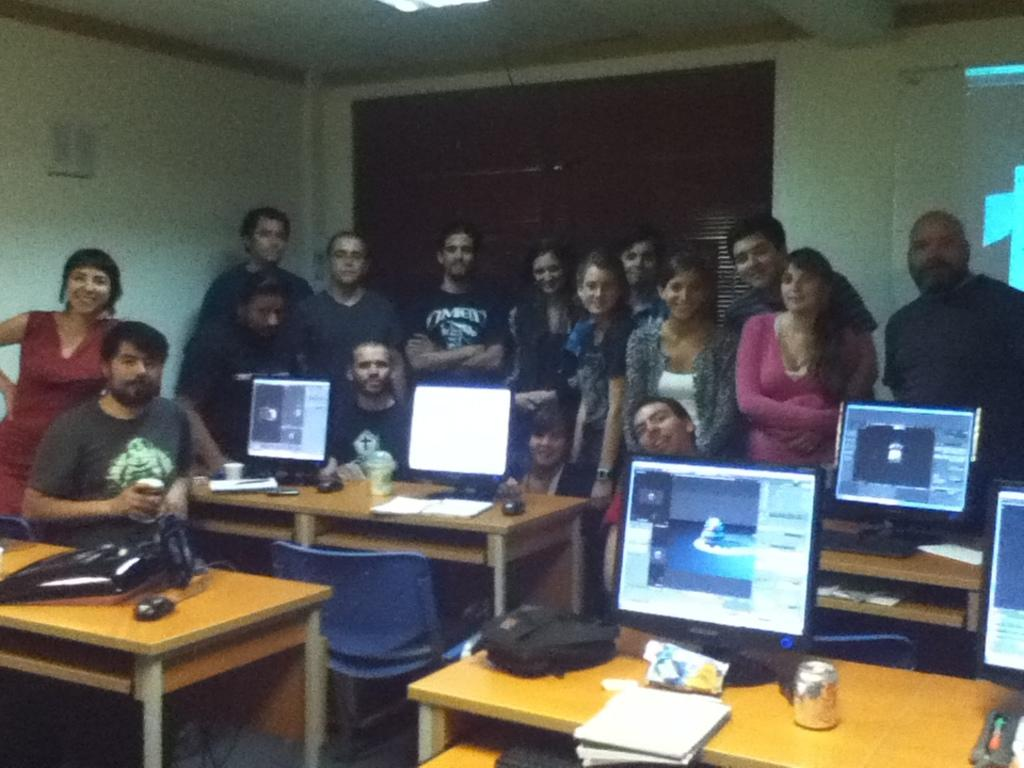How many people are in the image? There is a group of people in the image. What are the people in the image doing? The people are standing. What can be seen on the tables in the image? There are systems on the tables in the image. What type of acoustics can be heard in the image? There is no information about acoustics in the image, as it only shows a group of people standing and systems on tables. 